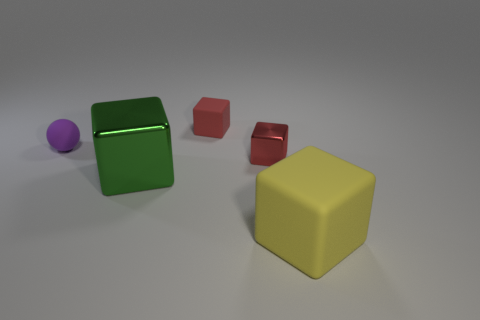Subtract all blue cylinders. How many red blocks are left? 2 Subtract all yellow cubes. How many cubes are left? 3 Subtract all green blocks. How many blocks are left? 3 Add 2 large purple things. How many objects exist? 7 Subtract 2 blocks. How many blocks are left? 2 Subtract all cubes. How many objects are left? 1 Subtract all gray cubes. Subtract all red spheres. How many cubes are left? 4 Subtract all small matte objects. Subtract all large red metal objects. How many objects are left? 3 Add 4 red shiny things. How many red shiny things are left? 5 Add 2 green objects. How many green objects exist? 3 